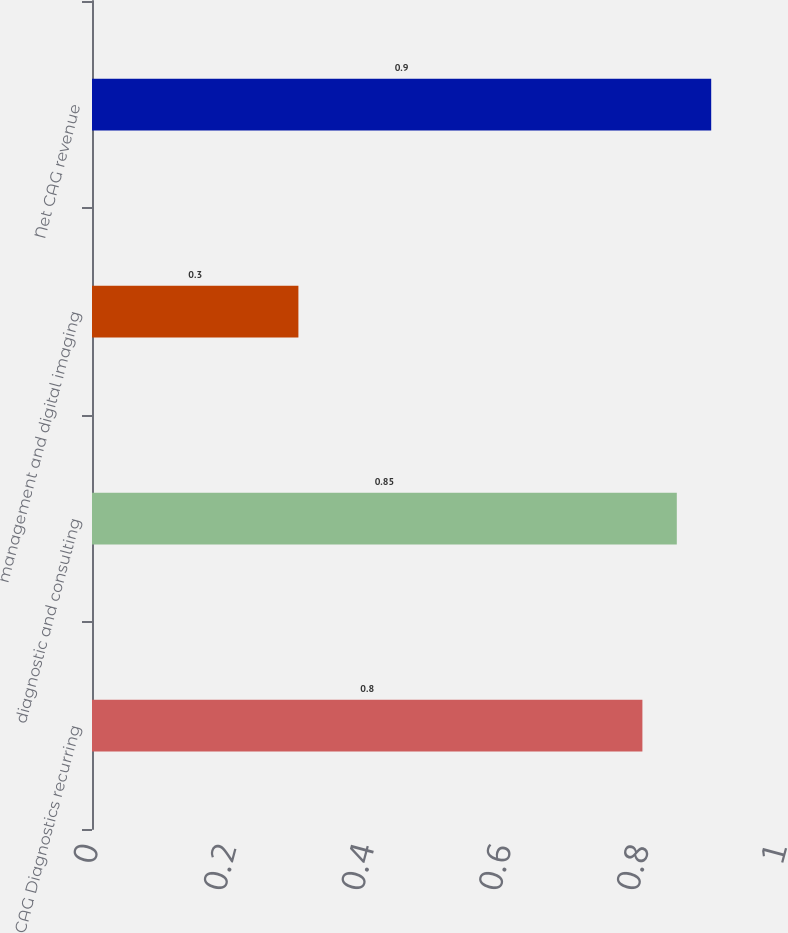<chart> <loc_0><loc_0><loc_500><loc_500><bar_chart><fcel>CAG Diagnostics recurring<fcel>diagnostic and consulting<fcel>management and digital imaging<fcel>Net CAG revenue<nl><fcel>0.8<fcel>0.85<fcel>0.3<fcel>0.9<nl></chart> 